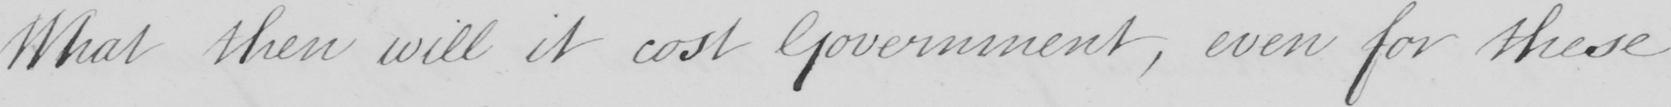Can you tell me what this handwritten text says? What then will it cost Government , even for these 